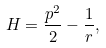Convert formula to latex. <formula><loc_0><loc_0><loc_500><loc_500>H = \frac { p ^ { 2 } } { 2 } - \frac { 1 } { r } ,</formula> 